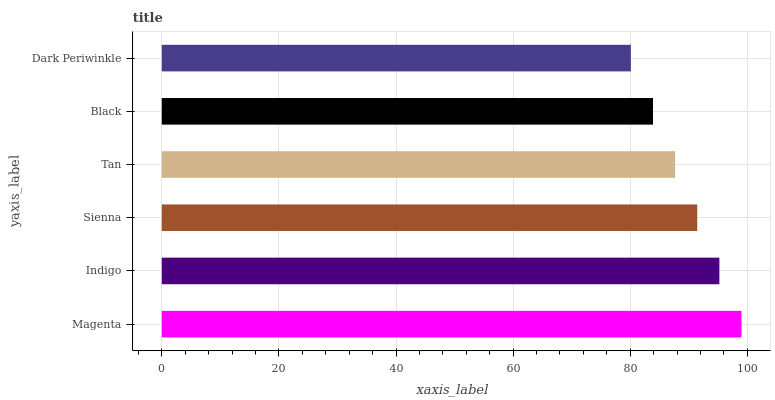Is Dark Periwinkle the minimum?
Answer yes or no. Yes. Is Magenta the maximum?
Answer yes or no. Yes. Is Indigo the minimum?
Answer yes or no. No. Is Indigo the maximum?
Answer yes or no. No. Is Magenta greater than Indigo?
Answer yes or no. Yes. Is Indigo less than Magenta?
Answer yes or no. Yes. Is Indigo greater than Magenta?
Answer yes or no. No. Is Magenta less than Indigo?
Answer yes or no. No. Is Sienna the high median?
Answer yes or no. Yes. Is Tan the low median?
Answer yes or no. Yes. Is Tan the high median?
Answer yes or no. No. Is Magenta the low median?
Answer yes or no. No. 